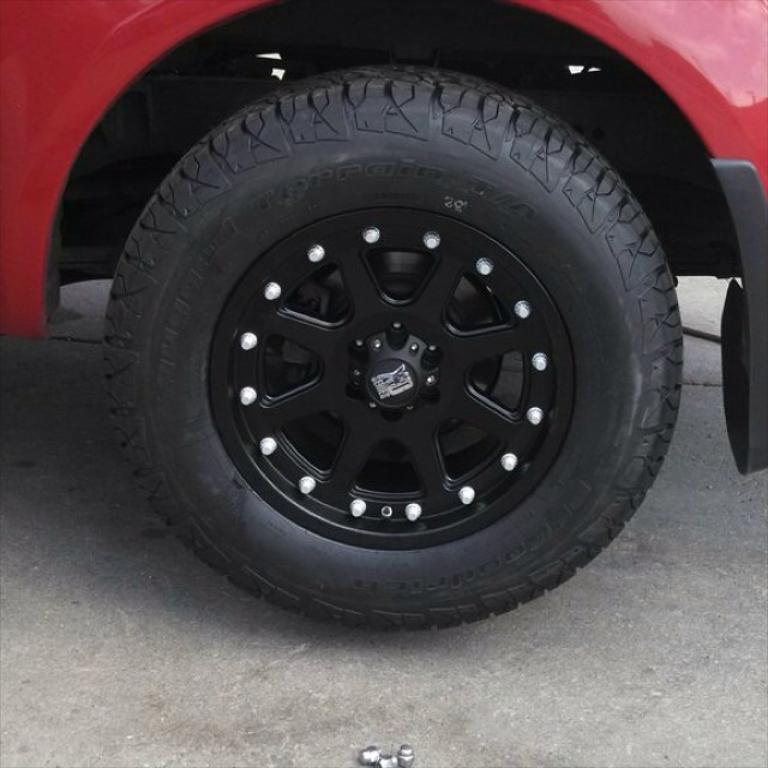What is the color of the vehicle in the image? The vehicle in the image is red. What part of the vehicle can be seen in the image? The wheel of the vehicle is visible. What is at the bottom of the image? There is a road at the bottom of the image. What type of summer clothing is the vehicle wearing in the image? The vehicle is not wearing any clothing, as it is an inanimate object. 